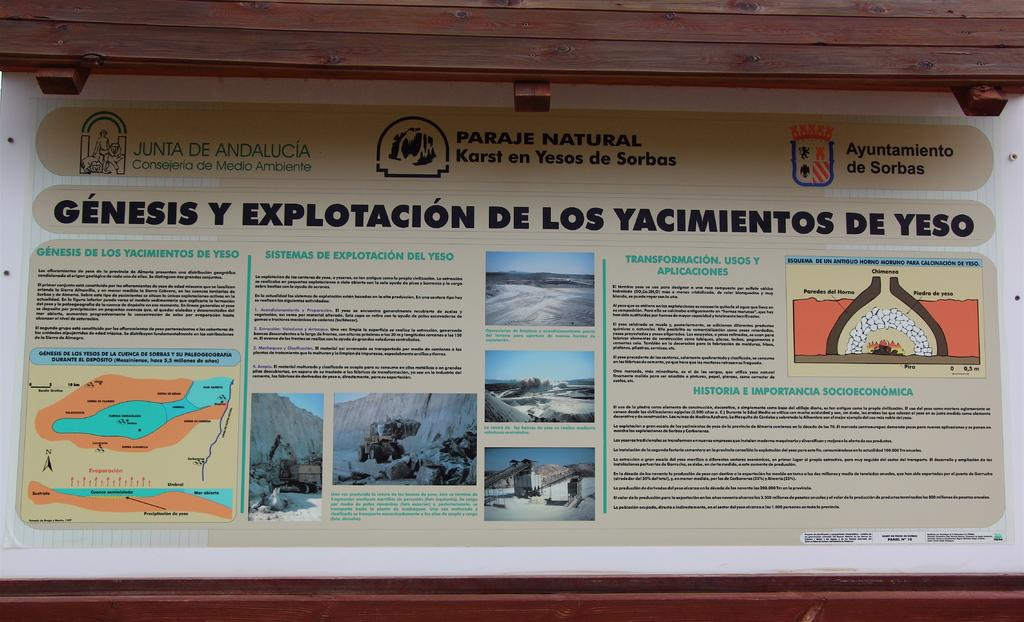<image>
Describe the image concisely. A sign for a paraje natural shows geographic features. 